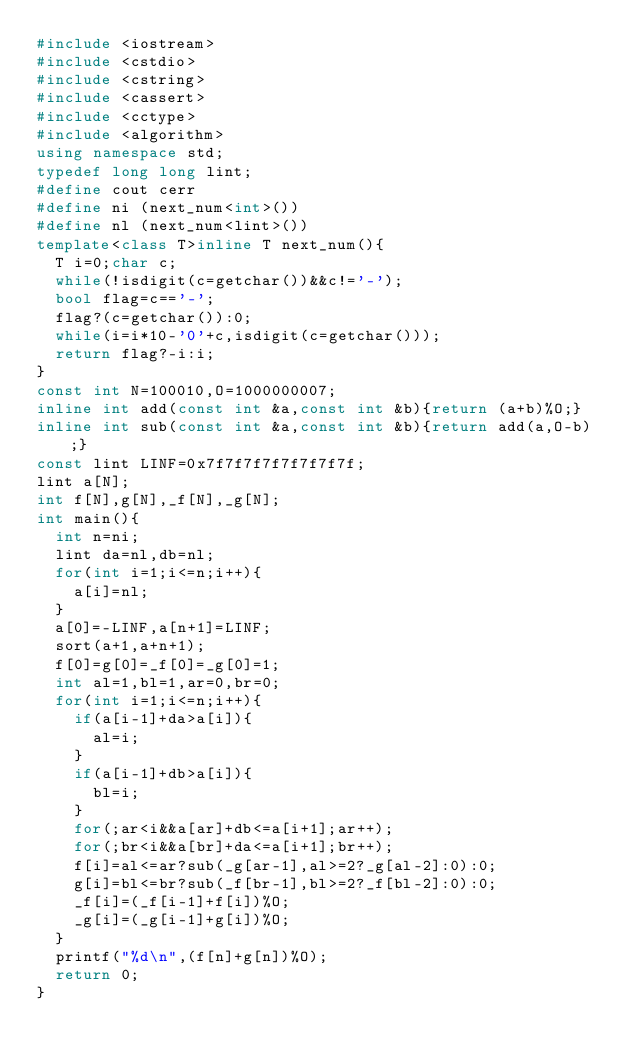Convert code to text. <code><loc_0><loc_0><loc_500><loc_500><_C++_>#include <iostream>
#include <cstdio>
#include <cstring>
#include <cassert>
#include <cctype>
#include <algorithm>
using namespace std;
typedef long long lint;
#define cout cerr
#define ni (next_num<int>())
#define nl (next_num<lint>())
template<class T>inline T next_num(){
	T i=0;char c;
	while(!isdigit(c=getchar())&&c!='-');
	bool flag=c=='-';
	flag?(c=getchar()):0;
	while(i=i*10-'0'+c,isdigit(c=getchar()));
	return flag?-i:i;
}
const int N=100010,O=1000000007;
inline int add(const int &a,const int &b){return (a+b)%O;}
inline int sub(const int &a,const int &b){return add(a,O-b);}
const lint LINF=0x7f7f7f7f7f7f7f7f;
lint a[N];
int f[N],g[N],_f[N],_g[N];
int main(){
	int n=ni;
	lint da=nl,db=nl;
	for(int i=1;i<=n;i++){
		a[i]=nl;
	}
	a[0]=-LINF,a[n+1]=LINF;
	sort(a+1,a+n+1);
	f[0]=g[0]=_f[0]=_g[0]=1;
	int al=1,bl=1,ar=0,br=0;
	for(int i=1;i<=n;i++){
		if(a[i-1]+da>a[i]){
			al=i;
		}
		if(a[i-1]+db>a[i]){
			bl=i;
		}
		for(;ar<i&&a[ar]+db<=a[i+1];ar++);
		for(;br<i&&a[br]+da<=a[i+1];br++);
		f[i]=al<=ar?sub(_g[ar-1],al>=2?_g[al-2]:0):0;
		g[i]=bl<=br?sub(_f[br-1],bl>=2?_f[bl-2]:0):0;
		_f[i]=(_f[i-1]+f[i])%O;
		_g[i]=(_g[i-1]+g[i])%O;
	}
	printf("%d\n",(f[n]+g[n])%O);
	return 0;
}</code> 